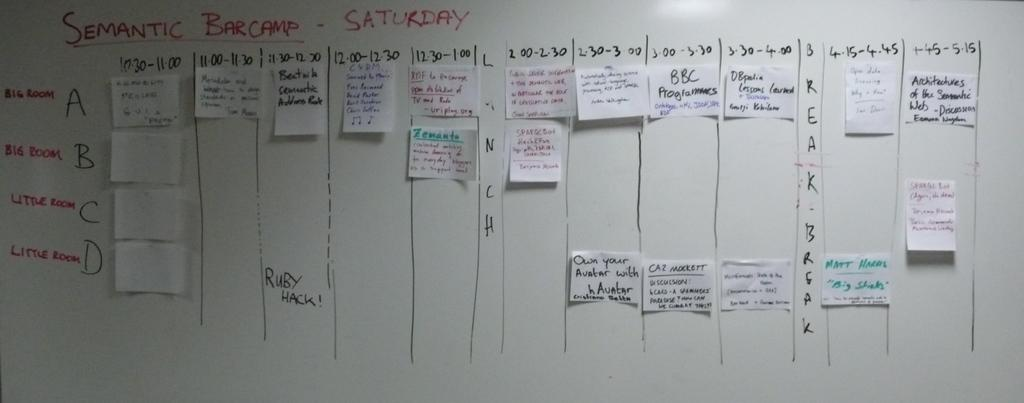<image>
Create a compact narrative representing the image presented. A board with hand written notes has Saturday written at the top. 